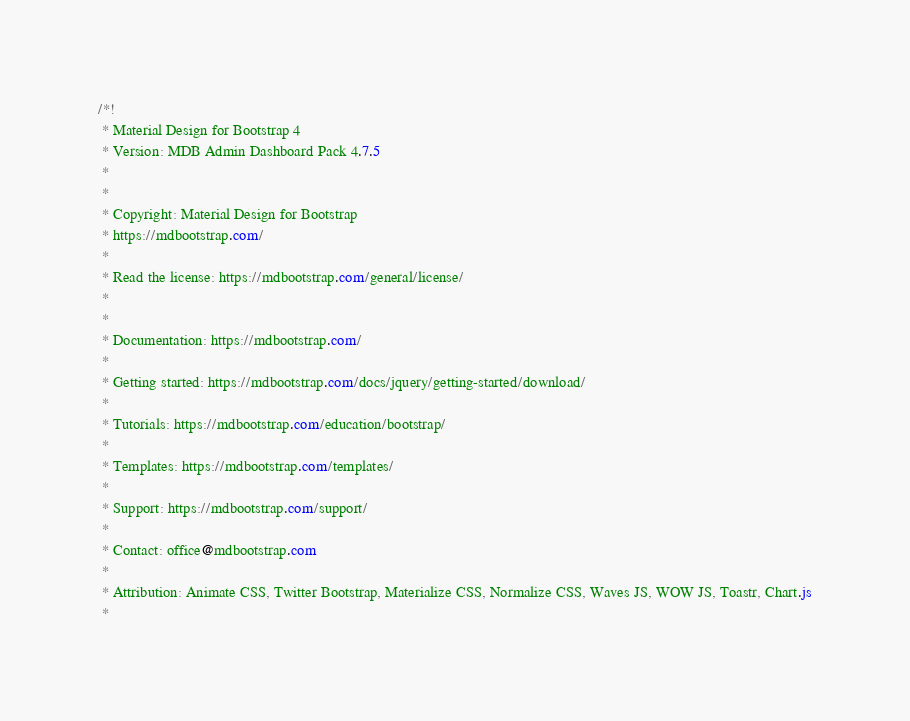<code> <loc_0><loc_0><loc_500><loc_500><_CSS_>/*!
 * Material Design for Bootstrap 4
 * Version: MDB Admin Dashboard Pack 4.7.5
 *
 *
 * Copyright: Material Design for Bootstrap
 * https://mdbootstrap.com/
 *
 * Read the license: https://mdbootstrap.com/general/license/
 *
 *
 * Documentation: https://mdbootstrap.com/
 *
 * Getting started: https://mdbootstrap.com/docs/jquery/getting-started/download/
 *
 * Tutorials: https://mdbootstrap.com/education/bootstrap/
 *
 * Templates: https://mdbootstrap.com/templates/
 *
 * Support: https://mdbootstrap.com/support/
 *
 * Contact: office@mdbootstrap.com
 *
 * Attribution: Animate CSS, Twitter Bootstrap, Materialize CSS, Normalize CSS, Waves JS, WOW JS, Toastr, Chart.js
 *</code> 